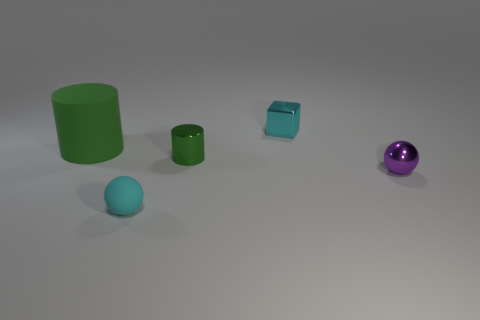What is the color of the small ball that is to the left of the purple ball that is right of the block?
Keep it short and to the point. Cyan. Are there any cubes of the same color as the large matte object?
Ensure brevity in your answer.  No. There is a cyan thing that is in front of the matte thing on the left side of the matte thing in front of the big rubber cylinder; what is its size?
Offer a terse response. Small. There is a tiny green thing; what shape is it?
Provide a succinct answer. Cylinder. There is a rubber thing that is the same color as the small cylinder; what size is it?
Ensure brevity in your answer.  Large. There is a small metallic thing that is to the right of the block; how many cyan metal cubes are on the left side of it?
Your answer should be very brief. 1. How many other objects are the same material as the big green cylinder?
Your answer should be compact. 1. Is the material of the small cyan object behind the large green cylinder the same as the cylinder to the left of the tiny cyan ball?
Keep it short and to the point. No. Are there any other things that have the same shape as the cyan metal object?
Give a very brief answer. No. Does the purple thing have the same material as the tiny cyan object that is behind the tiny purple metallic ball?
Your answer should be very brief. Yes. 